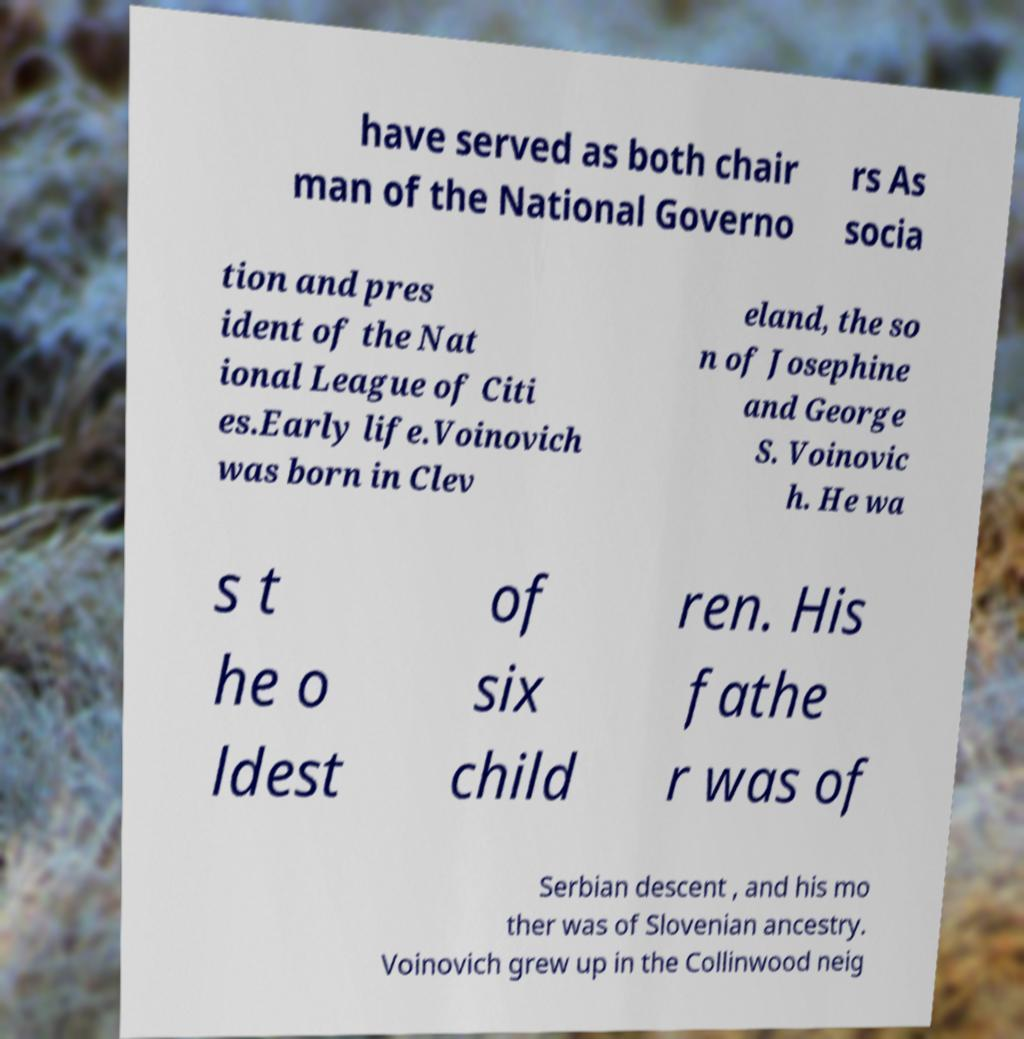Can you accurately transcribe the text from the provided image for me? have served as both chair man of the National Governo rs As socia tion and pres ident of the Nat ional League of Citi es.Early life.Voinovich was born in Clev eland, the so n of Josephine and George S. Voinovic h. He wa s t he o ldest of six child ren. His fathe r was of Serbian descent , and his mo ther was of Slovenian ancestry. Voinovich grew up in the Collinwood neig 